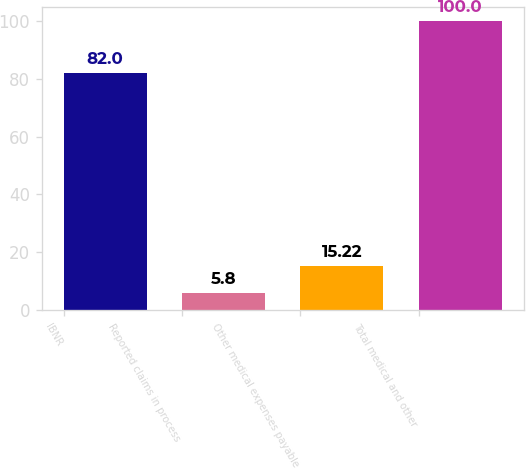Convert chart. <chart><loc_0><loc_0><loc_500><loc_500><bar_chart><fcel>IBNR<fcel>Reported claims in process<fcel>Other medical expenses payable<fcel>Total medical and other<nl><fcel>82<fcel>5.8<fcel>15.22<fcel>100<nl></chart> 